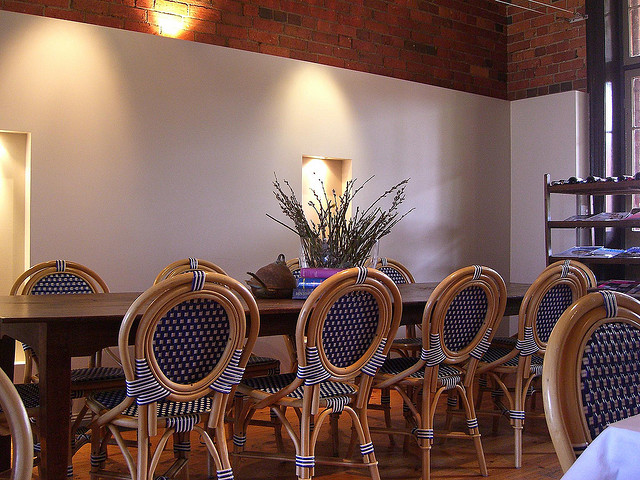<image>Is this a dinner setting? I am not sure if this is a dinner setting. It could be. Is this a dinner setting? I don't know if this is a dinner setting. It can be both a dinner setting or not. 